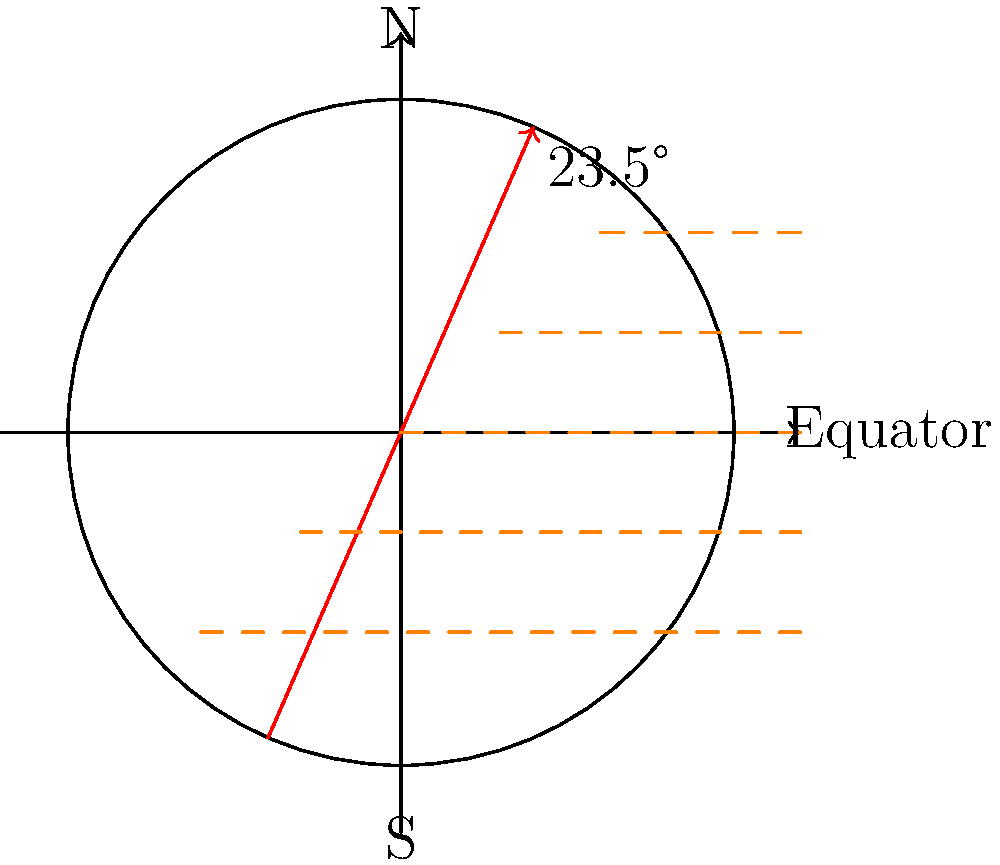Based on the diagram showing Earth's axial tilt, how does this tilt affect the efficiency of solar panels installed at different latitudes in urban environments throughout the year? To understand the impact of Earth's axial tilt on solar panel efficiency in urban environments at different latitudes, let's break it down step-by-step:

1. Earth's axial tilt: The diagram shows Earth's axis tilted at 23.5° relative to its orbital plane.

2. Seasonal variations:
   a. During summer in the Northern Hemisphere, the North Pole is tilted towards the Sun.
   b. During winter in the Northern Hemisphere, the North Pole is tilted away from the Sun.

3. Impact on solar radiation:
   a. The tilt causes variations in the angle at which sunlight hits the Earth's surface at different latitudes.
   b. This angle changes throughout the year as Earth orbits the Sun.

4. Solar panel efficiency:
   a. Solar panels are most efficient when sunlight hits them perpendicularly.
   b. The efficiency decreases as the angle of incidence increases.

5. Latitude effects:
   a. Equatorial regions (0° latitude):
      - Experience relatively consistent solar radiation year-round.
      - Solar panels can be installed at a fixed angle for optimal efficiency.
   b. Mid-latitudes (e.g., 30°-60°):
      - Experience significant seasonal variations in solar radiation.
      - Solar panels may require adjustable mounts or compromise angles for year-round efficiency.
   c. High latitudes (e.g., >60°):
      - Experience extreme variations in daylight hours and solar radiation.
      - Solar panels face challenges in winter months due to low sun angles and reduced daylight.

6. Urban environment considerations:
   a. Building orientation and shading effects become crucial factors.
   b. Vertical installation on building facades may be more practical in some urban settings.
   c. Rooftop installations need to account for latitude-specific optimal angles.

7. Optimization strategies:
   a. Use of tracking systems to follow the Sun's path.
   b. Seasonal manual adjustments of panel angles.
   c. Implementing a mix of panel orientations to capture light throughout the day and year.

In conclusion, Earth's axial tilt significantly impacts solar panel efficiency in urban environments across different latitudes. This necessitates careful consideration of installation angles, potential tracking systems, and seasonal adjustments to maximize energy production throughout the year.
Answer: Earth's axial tilt causes varying solar panel efficiency across latitudes, requiring latitude-specific installation angles and potential tracking systems in urban environments to optimize year-round energy production. 